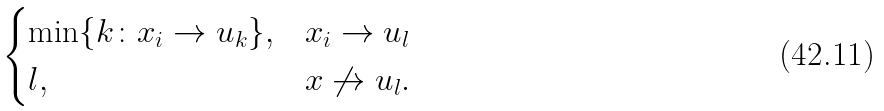Convert formula to latex. <formula><loc_0><loc_0><loc_500><loc_500>\begin{cases} \min \{ k \colon x _ { i } \to u _ { k } \} , & x _ { i } \to u _ { l } \\ l , & x \not \to u _ { l } . \end{cases}</formula> 